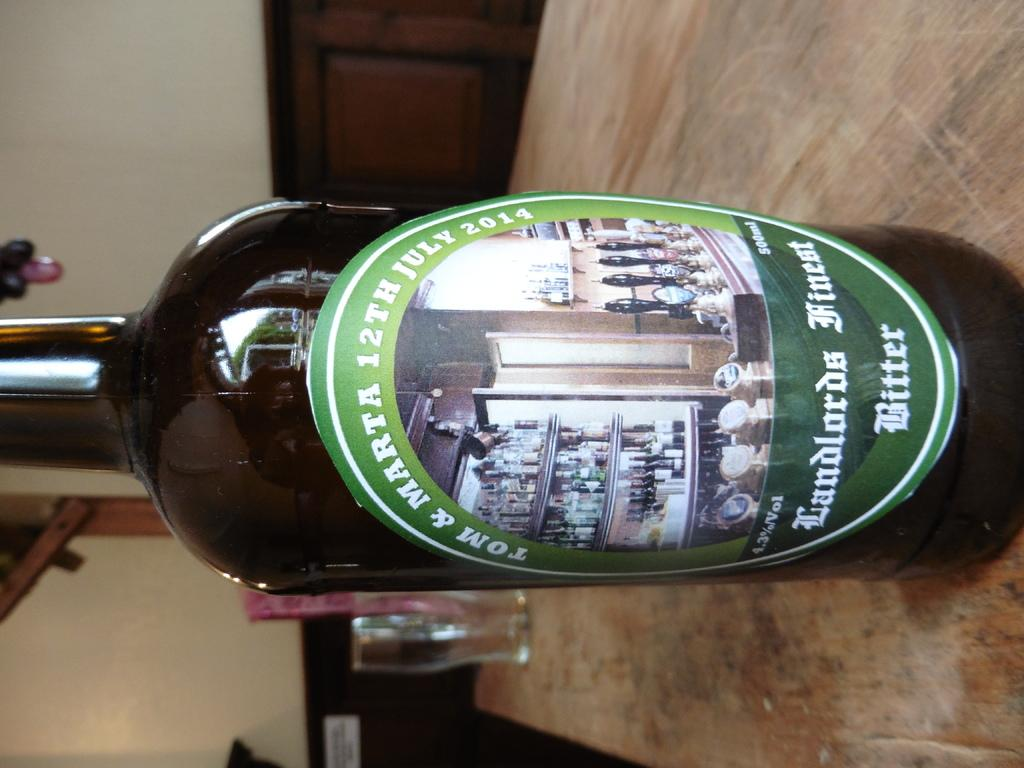Provide a one-sentence caption for the provided image. A bottle of Tom & Marta 12th July 2014 Landlords Finest Bitter. 